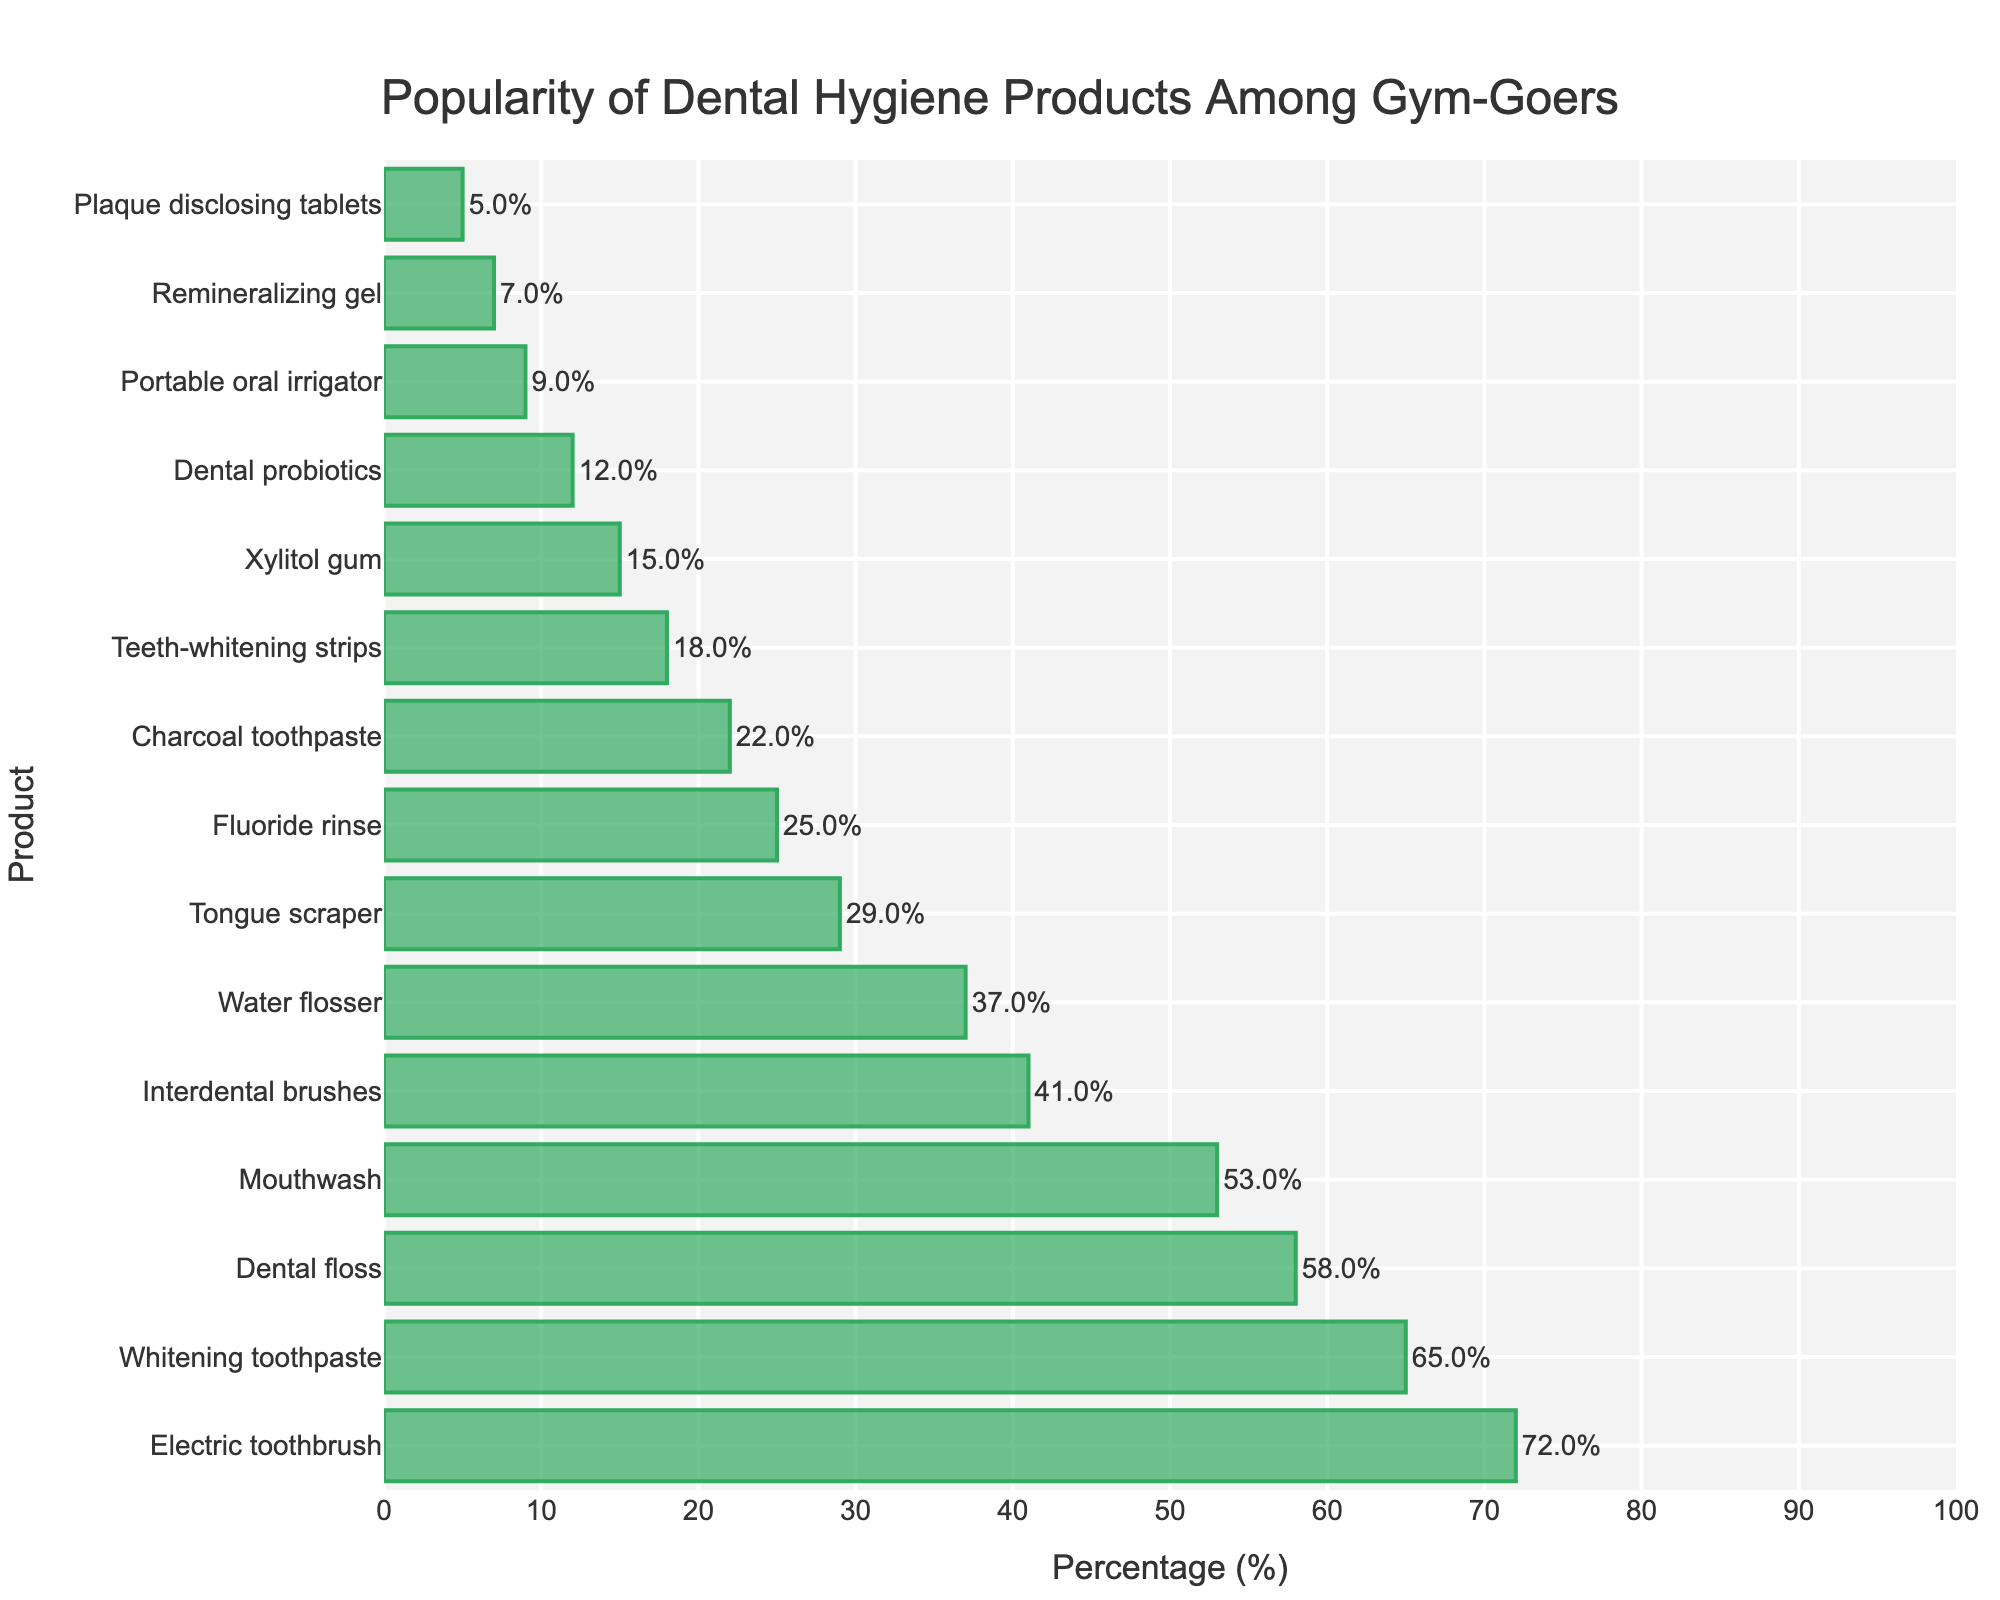What's the most popular dental hygiene product among gym-goers? The figure shows that the bar representing the "Electric toothbrush" is the longest, indicating it has the highest percentage.
Answer: Electric toothbrush Which dental hygiene product is used by 58% of gym-goers? From the figure, we observe that the "Dental floss" bar is aligned with a percentage of 58%.
Answer: Dental floss Are whitening toothpaste and dental floss more popular combined than mouthwash and interdental brushes combined? Adding the percentages: Whitening toothpaste (65) + Dental floss (58) = 123, and Mouthwash (53) + Interdental brushes (41) = 94. 123 is greater than 94.
Answer: Yes Which products have less than 20% popularity? The products with bars shorter than the 20% mark are Teeth-whitening strips, Xylitol gum, Dental probiotics, Portable oral irrigator, Remineralizing gel, and Plaque disclosing tablets.
Answer: Teeth-whitening strips, Xylitol gum, Dental probiotics, Portable oral irrigator, Remineralizing gel, Plaque disclosing tablets Is the usage of mouthwash closer to that of dental floss or to interdental brushes? The percentage for mouthwash is 53. Dental floss has 58 and interdental brushes have 41. The difference with dental floss is 5 and with interdental brushes is 12. Mouthwash is closer to dental floss.
Answer: Dental floss What is the percentage difference between the most and least popular dental hygiene products? The most popular product "Electric toothbrush" has 72%, and the least popular "Plaque disclosing tablets" has 5%. The difference is 72 - 5 = 67%.
Answer: 67% Which products have popularity percentages in the range of 30% to 50%? The products with bars aligning within the 30% to 50% range are Interdental brushes, Water flosser, and Tongue scraper.
Answer: Interdental brushes, Water flosser, Tongue scraper How many products have a popularity percentage above 50%? The bars whose percentages are above the 50% mark are Electric toothbrush, Whitening toothpaste, Dental floss, and Mouthwash, so there are 4 products in total.
Answer: 4 Which is more popular: Tongue scraper or Charcoal toothpaste? The bar representing the Tongue scraper (29%) is longer than the bar for Charcoal toothpaste (22%).
Answer: Tongue scraper What is the total percentage of all the products together? Add all the given percentages: 72 + 65 + 58 + 53 + 41 + 37 + 29 + 25 + 22 + 18 + 15 + 12 + 9 + 7 + 5 = 468.
Answer: 468% 